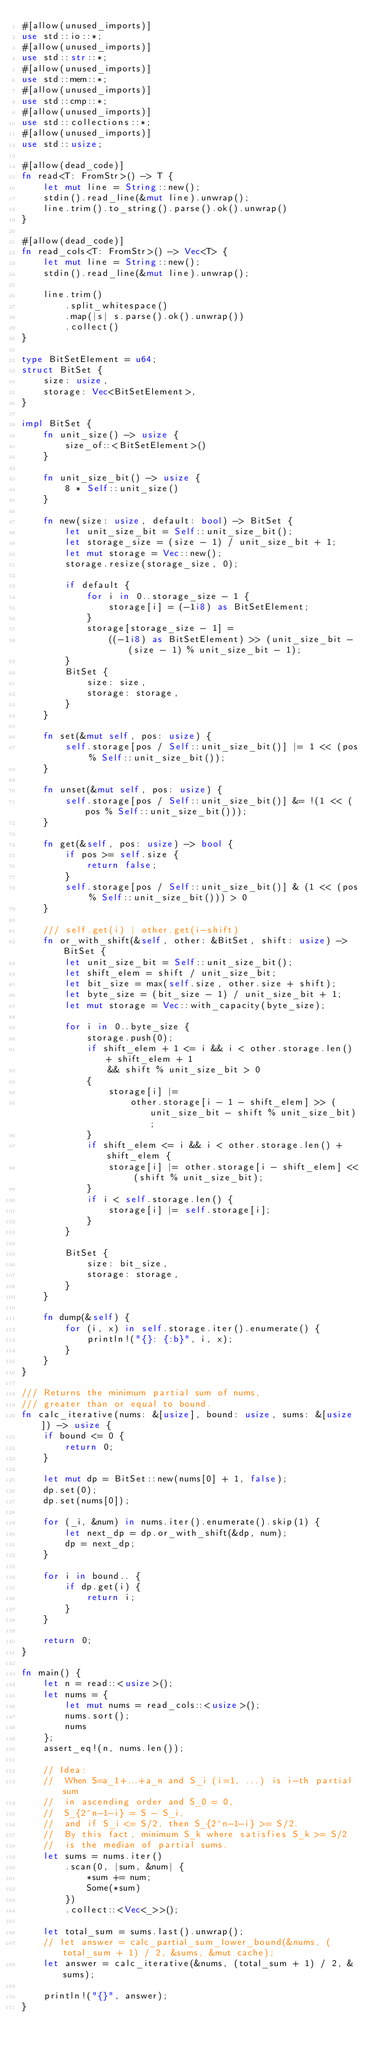<code> <loc_0><loc_0><loc_500><loc_500><_Rust_>#[allow(unused_imports)]
use std::io::*;
#[allow(unused_imports)]
use std::str::*;
#[allow(unused_imports)]
use std::mem::*;
#[allow(unused_imports)]
use std::cmp::*;
#[allow(unused_imports)]
use std::collections::*;
#[allow(unused_imports)]
use std::usize;

#[allow(dead_code)]
fn read<T: FromStr>() -> T {
    let mut line = String::new();
    stdin().read_line(&mut line).unwrap();
    line.trim().to_string().parse().ok().unwrap()
}

#[allow(dead_code)]
fn read_cols<T: FromStr>() -> Vec<T> {
    let mut line = String::new();
    stdin().read_line(&mut line).unwrap();

    line.trim()
        .split_whitespace()
        .map(|s| s.parse().ok().unwrap())
        .collect()
}

type BitSetElement = u64;
struct BitSet {
    size: usize,
    storage: Vec<BitSetElement>,
}

impl BitSet {
    fn unit_size() -> usize {
        size_of::<BitSetElement>()
    }

    fn unit_size_bit() -> usize {
        8 * Self::unit_size()
    }

    fn new(size: usize, default: bool) -> BitSet {
        let unit_size_bit = Self::unit_size_bit();
        let storage_size = (size - 1) / unit_size_bit + 1;
        let mut storage = Vec::new();
        storage.resize(storage_size, 0);

        if default {
            for i in 0..storage_size - 1 {
                storage[i] = (-1i8) as BitSetElement;
            }
            storage[storage_size - 1] =
                ((-1i8) as BitSetElement) >> (unit_size_bit - (size - 1) % unit_size_bit - 1);
        }
        BitSet {
            size: size,
            storage: storage,
        }
    }

    fn set(&mut self, pos: usize) {
        self.storage[pos / Self::unit_size_bit()] |= 1 << (pos % Self::unit_size_bit());
    }

    fn unset(&mut self, pos: usize) {
        self.storage[pos / Self::unit_size_bit()] &= !(1 << (pos % Self::unit_size_bit()));
    }

    fn get(&self, pos: usize) -> bool {
        if pos >= self.size {
            return false;
        }
        self.storage[pos / Self::unit_size_bit()] & (1 << (pos % Self::unit_size_bit())) > 0
    }

    /// self.get(i) | other.get(i-shift)
    fn or_with_shift(&self, other: &BitSet, shift: usize) -> BitSet {
        let unit_size_bit = Self::unit_size_bit();
        let shift_elem = shift / unit_size_bit;
        let bit_size = max(self.size, other.size + shift);
        let byte_size = (bit_size - 1) / unit_size_bit + 1;
        let mut storage = Vec::with_capacity(byte_size);

        for i in 0..byte_size {
            storage.push(0);
            if shift_elem + 1 <= i && i < other.storage.len() + shift_elem + 1
                && shift % unit_size_bit > 0
            {
                storage[i] |=
                    other.storage[i - 1 - shift_elem] >> (unit_size_bit - shift % unit_size_bit);
            }
            if shift_elem <= i && i < other.storage.len() + shift_elem {
                storage[i] |= other.storage[i - shift_elem] << (shift % unit_size_bit);
            }
            if i < self.storage.len() {
                storage[i] |= self.storage[i];
            }
        }

        BitSet {
            size: bit_size,
            storage: storage,
        }
    }

    fn dump(&self) {
        for (i, x) in self.storage.iter().enumerate() {
            println!("{}: {:b}", i, x);
        }
    }
}

/// Returns the minimum partial sum of nums,
/// greater than or equal to bound.
fn calc_iterative(nums: &[usize], bound: usize, sums: &[usize]) -> usize {
    if bound <= 0 {
        return 0;
    }

    let mut dp = BitSet::new(nums[0] + 1, false);
    dp.set(0);
    dp.set(nums[0]);

    for (_i, &num) in nums.iter().enumerate().skip(1) {
        let next_dp = dp.or_with_shift(&dp, num);
        dp = next_dp;
    }

    for i in bound.. {
        if dp.get(i) {
            return i;
        }
    }

    return 0;
}

fn main() {
    let n = read::<usize>();
    let nums = {
        let mut nums = read_cols::<usize>();
        nums.sort();
        nums
    };
    assert_eq!(n, nums.len());

    // Idea:
    //  When S=a_1+...+a_n and S_i (i=1, ...) is i-th partial sum
    //  in ascending order and S_0 = 0,
    //  S_{2^n-1-i} = S - S_i,
    //  and if S_i <= S/2, then S_{2^n-1-i} >= S/2.
    //  By this fact, minimum S_k where satisfies S_k >= S/2
    //  is the median of partial sums.
    let sums = nums.iter()
        .scan(0, |sum, &num| {
            *sum += num;
            Some(*sum)
        })
        .collect::<Vec<_>>();

    let total_sum = sums.last().unwrap();
    // let answer = calc_partial_sum_lower_bound(&nums, (total_sum + 1) / 2, &sums, &mut cache);
    let answer = calc_iterative(&nums, (total_sum + 1) / 2, &sums);

    println!("{}", answer);
}</code> 